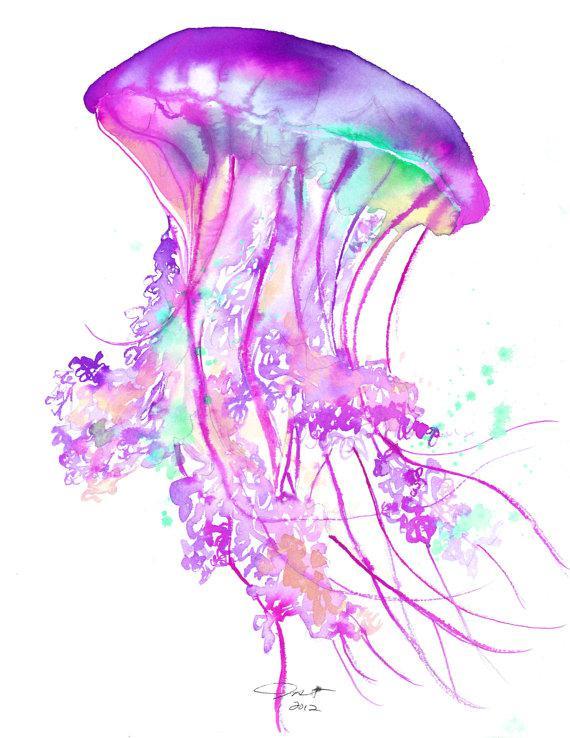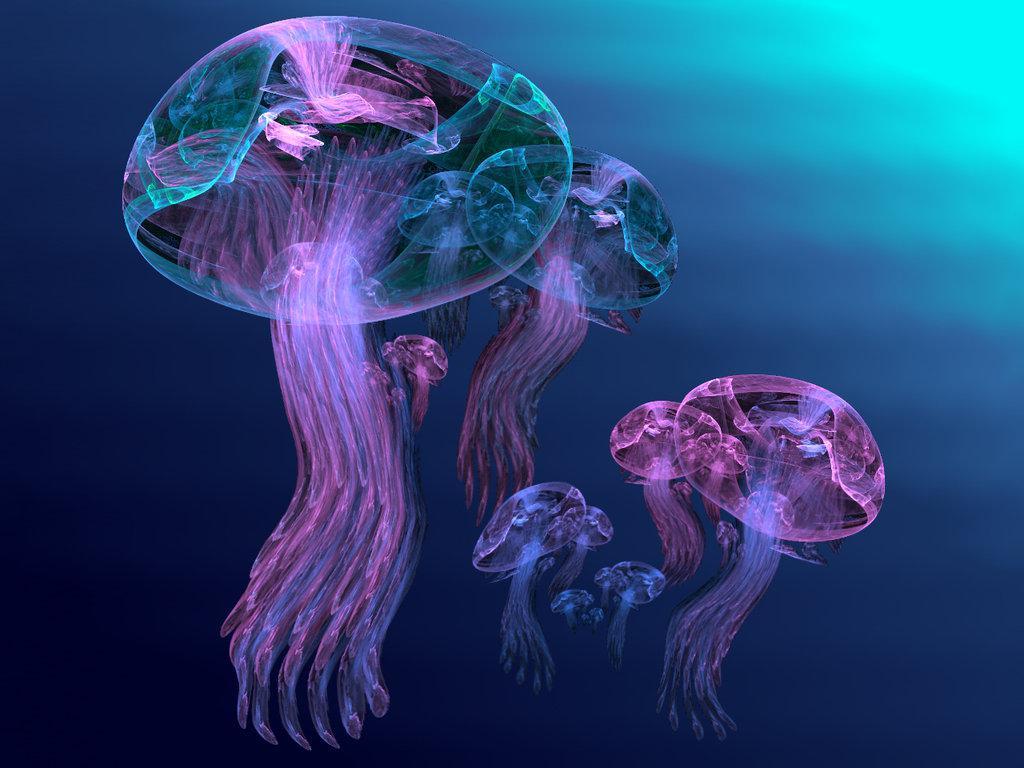The first image is the image on the left, the second image is the image on the right. Examine the images to the left and right. Is the description "There are multiple jellyfish in water in the right image." accurate? Answer yes or no. Yes. The first image is the image on the left, the second image is the image on the right. For the images shown, is this caption "Left image shows multiple disk-shaped hot-pink jellyfish on a blue background." true? Answer yes or no. No. 